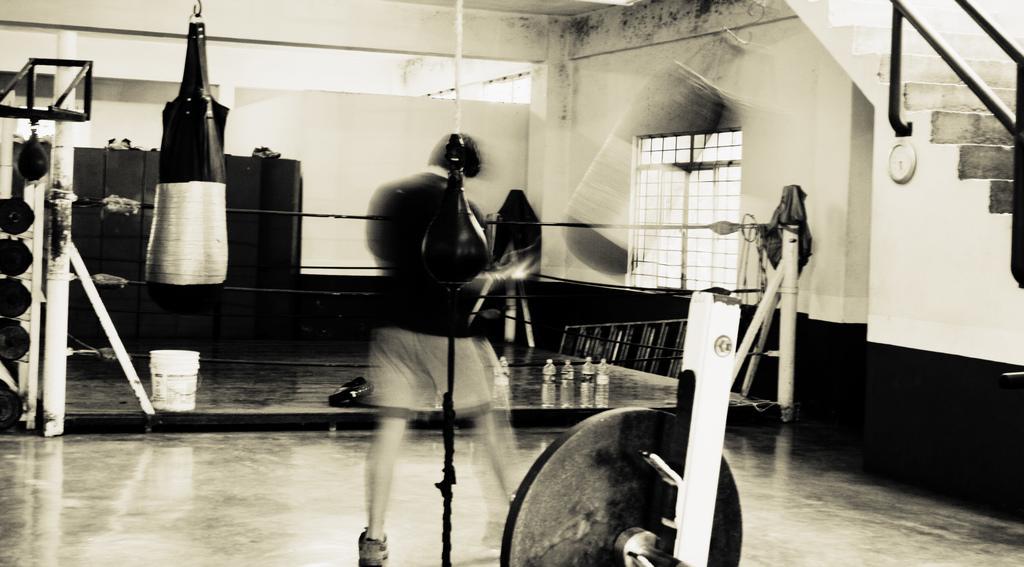Please provide a concise description of this image. In front of the image there is a metal object. Behind the metal object there is a rope and a person. In front of the person there is a punching bag and a boxing ring. Inside the ring there are bottles of water and a bucket. On the other side of the ring there is a ladder. Behind the ring there are lockers. On the left side of the image behind the metal pole there are some metal objects. In the background of the image on the wall there is a grill window and a watch. Behind the watch there are stairs with metal rod fence. 